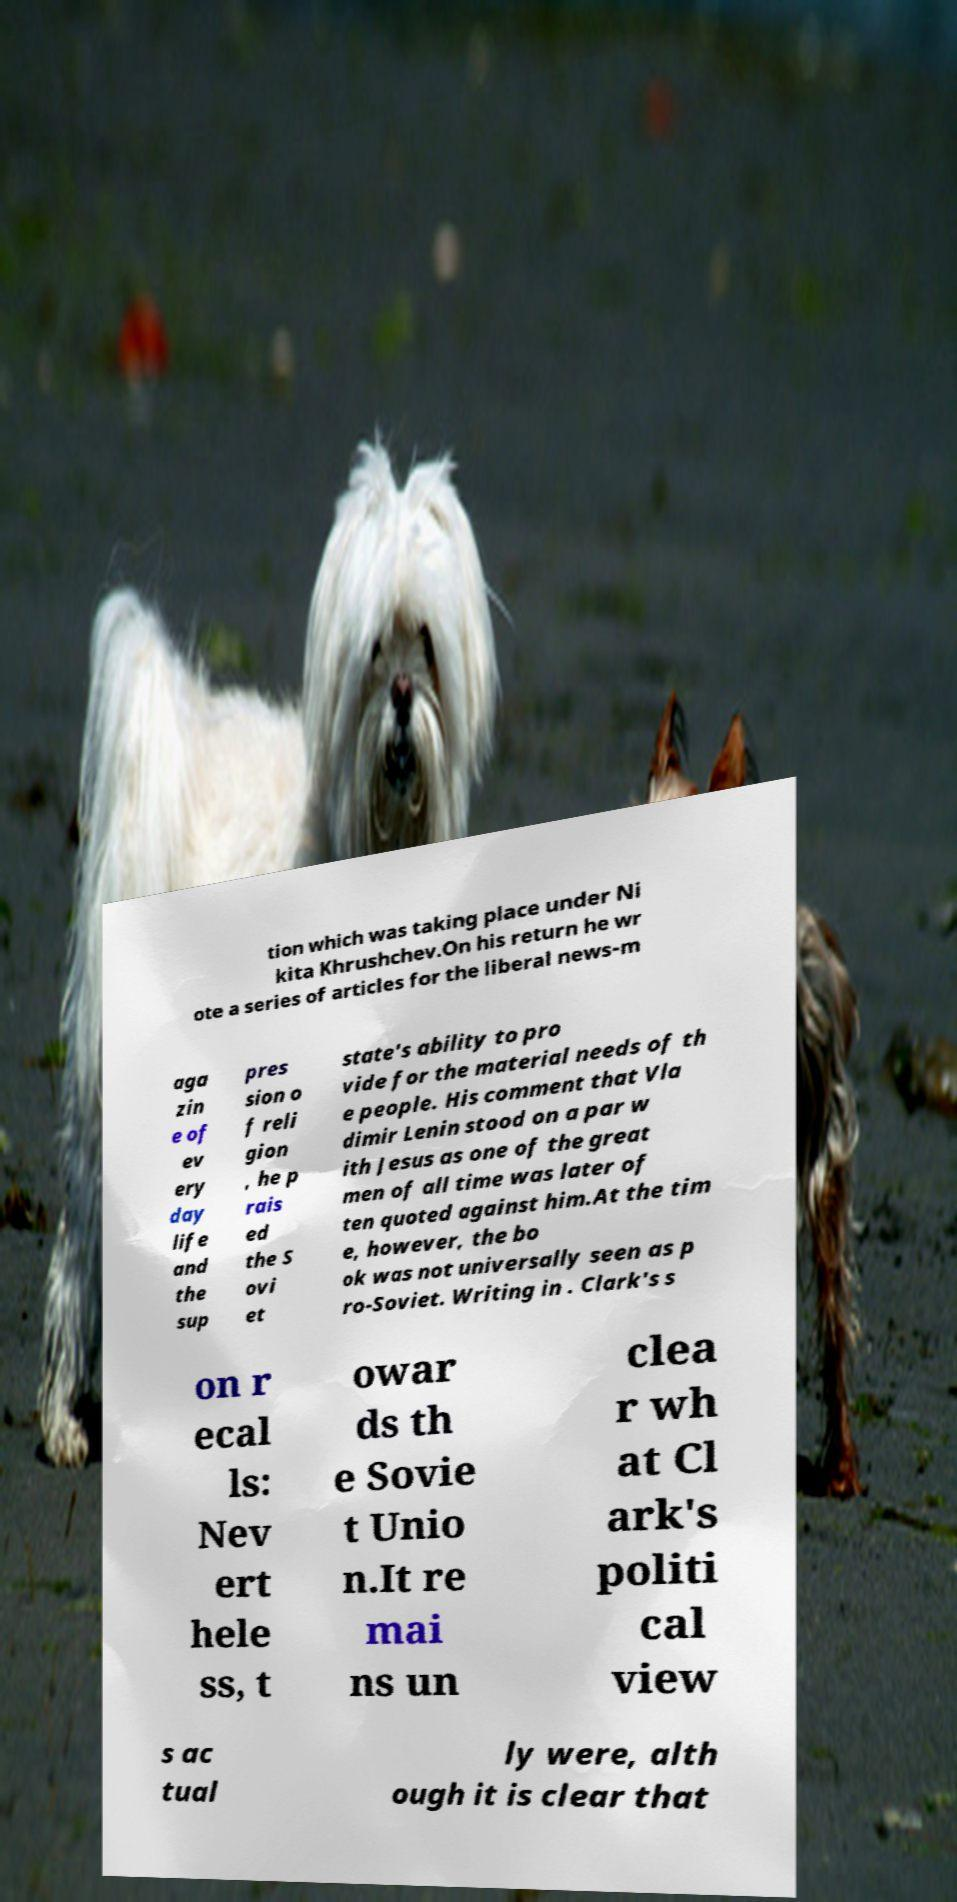Please identify and transcribe the text found in this image. tion which was taking place under Ni kita Khrushchev.On his return he wr ote a series of articles for the liberal news-m aga zin e of ev ery day life and the sup pres sion o f reli gion , he p rais ed the S ovi et state's ability to pro vide for the material needs of th e people. His comment that Vla dimir Lenin stood on a par w ith Jesus as one of the great men of all time was later of ten quoted against him.At the tim e, however, the bo ok was not universally seen as p ro-Soviet. Writing in . Clark's s on r ecal ls: Nev ert hele ss, t owar ds th e Sovie t Unio n.It re mai ns un clea r wh at Cl ark's politi cal view s ac tual ly were, alth ough it is clear that 